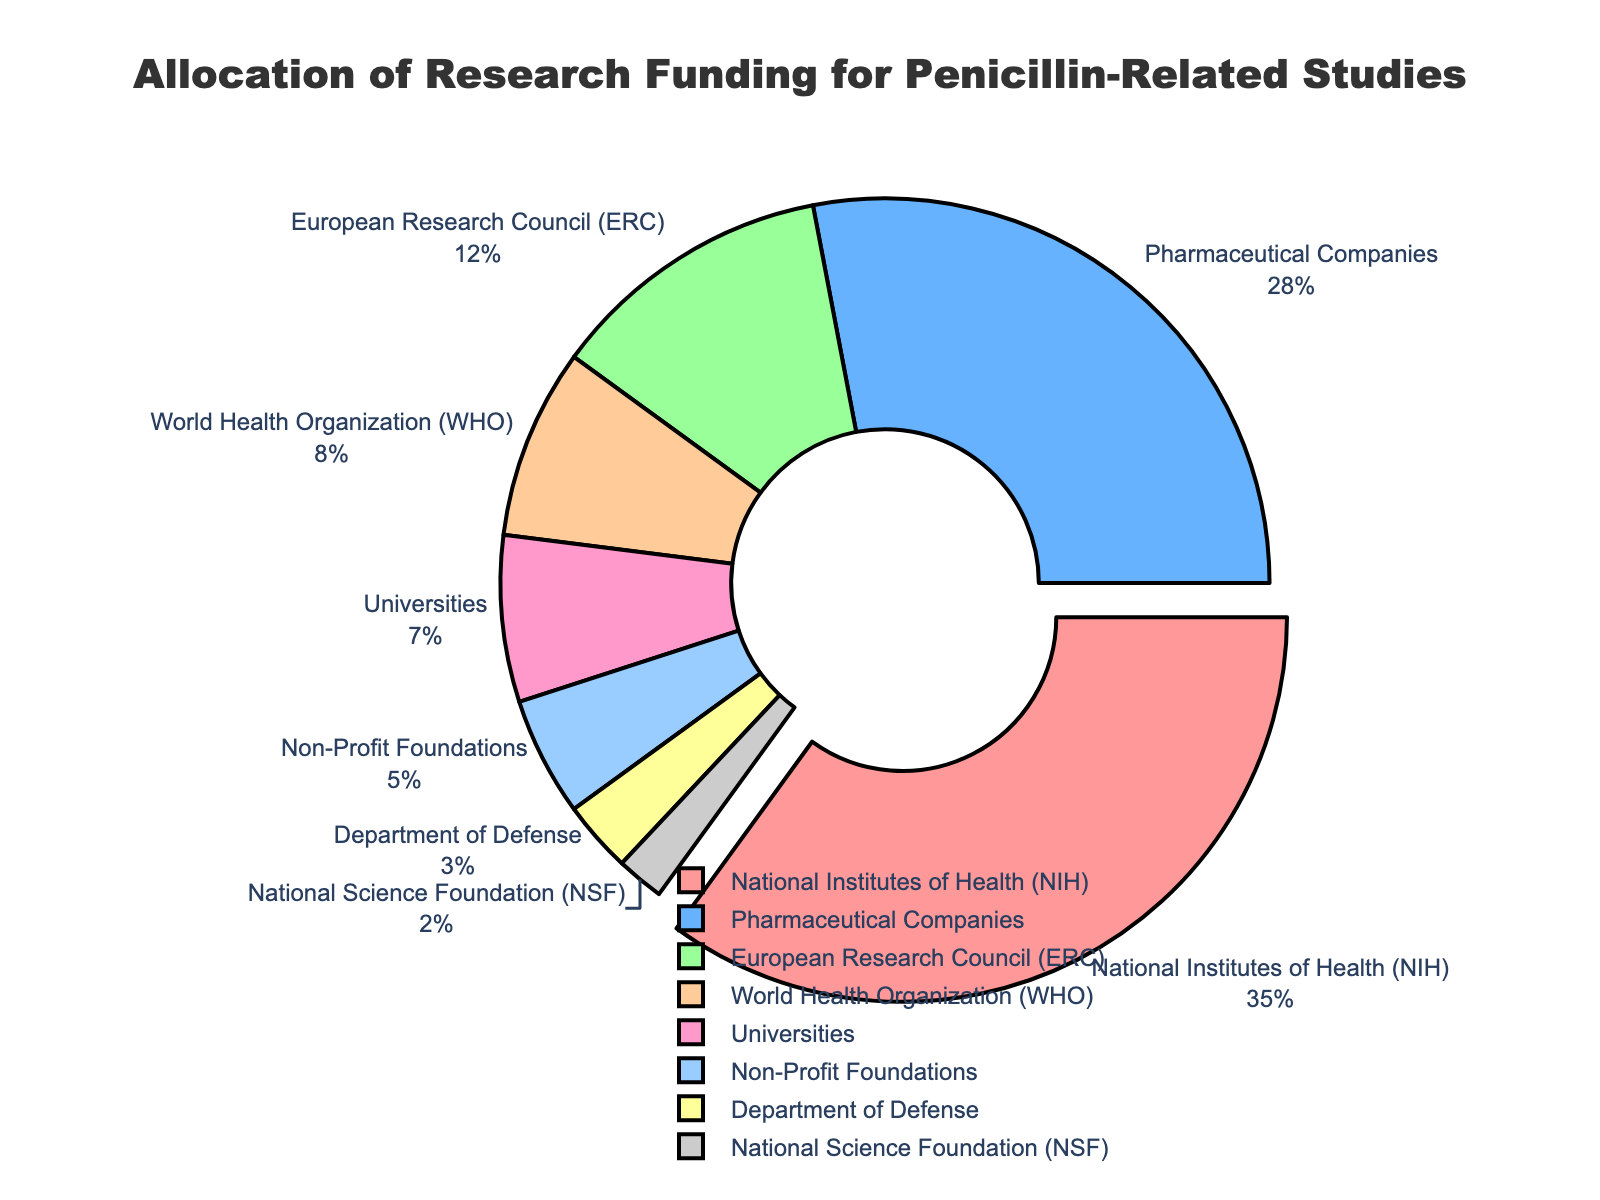What is the largest funding source for penicillin-related studies? The figure shows that the National Institutes of Health (NIH) has the largest slice of the pie chart, which represents 35% of the total funding.
Answer: National Institutes of Health (NIH) Which funding sources have percentages less than 10%? The pie chart shows that the funding sources with percentages less than 10% are the World Health Organization (WHO) at 8%, Universities at 7%, Non-Profit Foundations at 5%, Department of Defense at 3%, and National Science Foundation (NSF) at 2%.
Answer: World Health Organization (WHO), Universities, Non-Profit Foundations, Department of Defense, National Science Foundation (NSF) Which two sources combined contribute more funding than the National Institutes of Health (NIH)? From the chart, the NIH contributes 35%. The two sources with the next largest contributions are Pharmaceutical Companies at 28% and European Research Council (ERC) at 12%. Their combined total is 28% + 12% = 40%, which is more than that of NIH.
Answer: Pharmaceutical Companies and European Research Council (ERC) What is the combined funding percentage for organizations associated with governments? Government-associated organizations in the chart include National Institutes of Health (NIH) at 35%, World Health Organization (WHO) at 8%, Department of Defense at 3%, and National Science Foundation (NSF) at 2%. The combined funding is 35% + 8% + 3% + 2% = 48%.
Answer: 48% What percentage more does the NIH contribute compared to the Department of Defense? The NIH contributes 35%, and the Department of Defense contributes 3%. The difference is 35% - 3% = 32%.
Answer: 32% Which segment is pulled out from the pie chart and what does it signify? The segment for National Institutes of Health (NIH) is pulled out from the pie chart. This signifies that NIH is the largest single contributor at 35%.
Answer: National Institutes of Health (NIH) What is the approximate ratio of funding between Pharmaceutical Companies and Non-Profit Foundations? The chart shows that Pharmaceutical Companies contribute 28% and Non-Profit Foundations contribute 5%. The approximate ratio is 28:5, which simplifies to approximately 5.6:1.
Answer: 5.6:1 How does the funding percentage from Pharmaceutical Companies compare to that from Universities? The chart indicates that Pharmaceutical Companies contribute 28% while Universities contribute 7%. Pharmaceutical Companies contribute 4 times (28% ÷ 7%) as much as Universities.
Answer: 4 times If the total funding for penicillin-related research is $100 million, how much do the Non-Profit Foundations contribute? Non-Profit Foundations contribute 5% of the total funding. So, 5% of $100 million is calculated as ($100 million * 0.05) = $5 million.
Answer: $5 million What proportion of the chart is attributed to the European Research Council (ERC) and how is this visually represented? The European Research Council (ERC) accounts for 12% of the funding. Visually, this is represented by a segment of the pie chart with a size corresponding to 12% of the whole chart.
Answer: 12% 